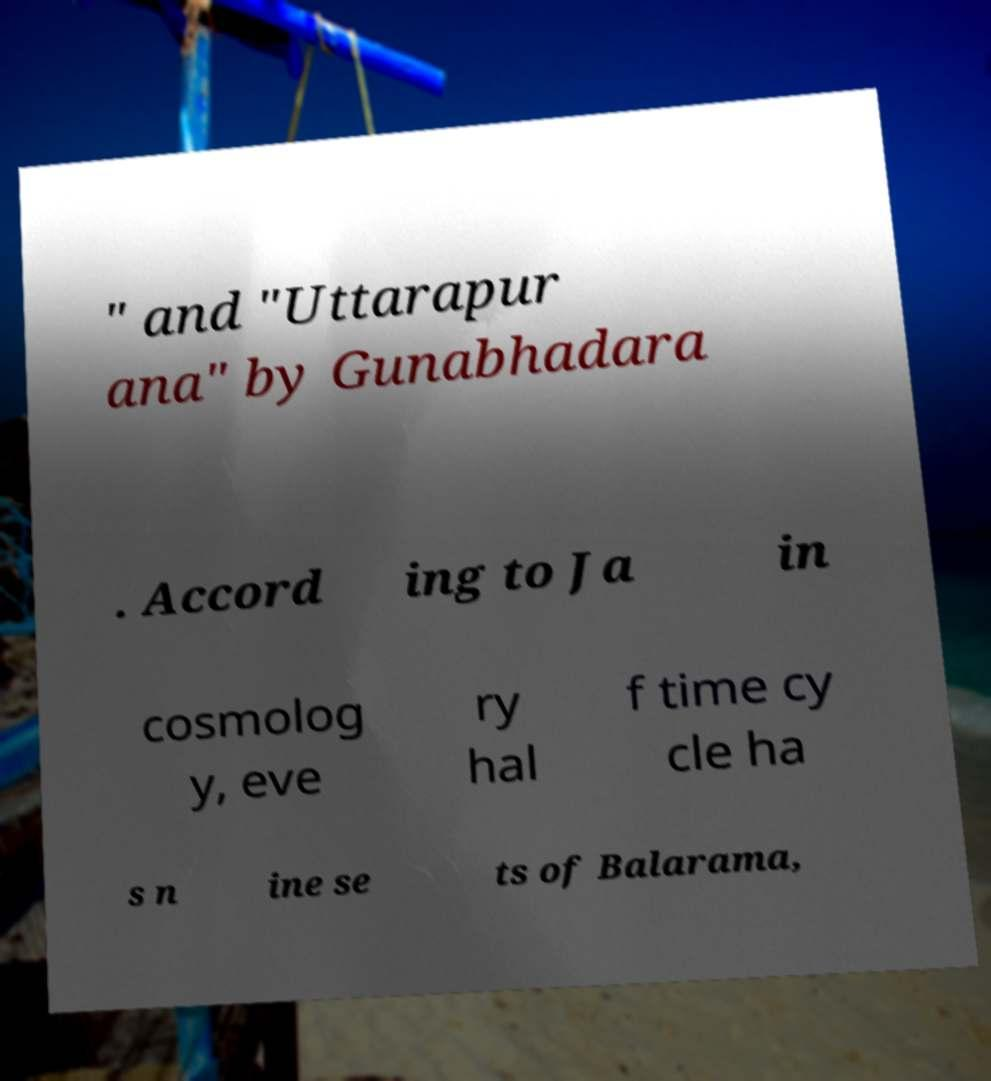Can you read and provide the text displayed in the image?This photo seems to have some interesting text. Can you extract and type it out for me? " and "Uttarapur ana" by Gunabhadara . Accord ing to Ja in cosmolog y, eve ry hal f time cy cle ha s n ine se ts of Balarama, 